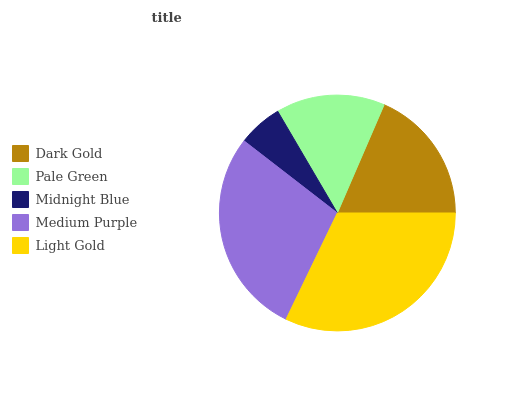Is Midnight Blue the minimum?
Answer yes or no. Yes. Is Light Gold the maximum?
Answer yes or no. Yes. Is Pale Green the minimum?
Answer yes or no. No. Is Pale Green the maximum?
Answer yes or no. No. Is Dark Gold greater than Pale Green?
Answer yes or no. Yes. Is Pale Green less than Dark Gold?
Answer yes or no. Yes. Is Pale Green greater than Dark Gold?
Answer yes or no. No. Is Dark Gold less than Pale Green?
Answer yes or no. No. Is Dark Gold the high median?
Answer yes or no. Yes. Is Dark Gold the low median?
Answer yes or no. Yes. Is Medium Purple the high median?
Answer yes or no. No. Is Midnight Blue the low median?
Answer yes or no. No. 